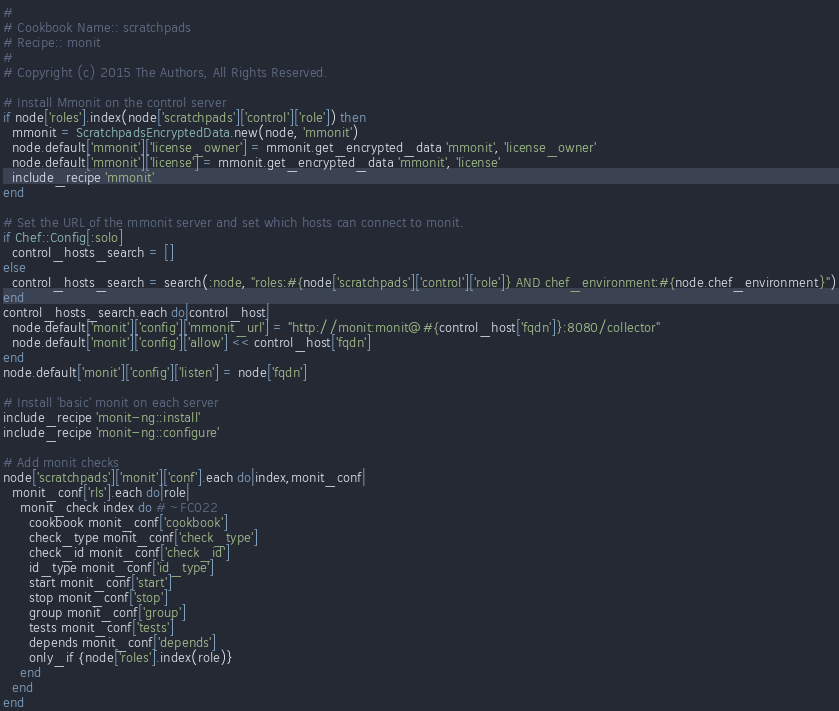Convert code to text. <code><loc_0><loc_0><loc_500><loc_500><_Ruby_>#
# Cookbook Name:: scratchpads
# Recipe:: monit
#
# Copyright (c) 2015 The Authors, All Rights Reserved.

# Install Mmonit on the control server
if node['roles'].index(node['scratchpads']['control']['role']) then
  mmonit = ScratchpadsEncryptedData.new(node, 'mmonit')
  node.default['mmonit']['license_owner'] = mmonit.get_encrypted_data 'mmonit', 'license_owner'
  node.default['mmonit']['license'] = mmonit.get_encrypted_data 'mmonit', 'license'
  include_recipe 'mmonit'
end

# Set the URL of the mmonit server and set which hosts can connect to monit.
if Chef::Config[:solo]
  control_hosts_search = []
else
  control_hosts_search = search(:node, "roles:#{node['scratchpads']['control']['role']} AND chef_environment:#{node.chef_environment}")
end
control_hosts_search.each do|control_host|
  node.default['monit']['config']['mmonit_url'] = "http://monit:monit@#{control_host['fqdn']}:8080/collector"
  node.default['monit']['config']['allow'] << control_host['fqdn']
end
node.default['monit']['config']['listen'] = node['fqdn']

# Install 'basic' monit on each server
include_recipe 'monit-ng::install'
include_recipe 'monit-ng::configure'

# Add monit checks
node['scratchpads']['monit']['conf'].each do|index,monit_conf|
  monit_conf['rls'].each do|role|
    monit_check index do # ~FC022
      cookbook monit_conf['cookbook']
      check_type monit_conf['check_type']
      check_id monit_conf['check_id']
      id_type monit_conf['id_type']
      start monit_conf['start']
      stop monit_conf['stop']
      group monit_conf['group']
      tests monit_conf['tests']
      depends monit_conf['depends']
      only_if {node['roles'].index(role)}
    end
  end
end</code> 